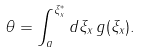<formula> <loc_0><loc_0><loc_500><loc_500>\theta = \int _ { a } ^ { \xi _ { x } ^ { * } } d \xi _ { x } \, g ( \xi _ { x } ) .</formula> 